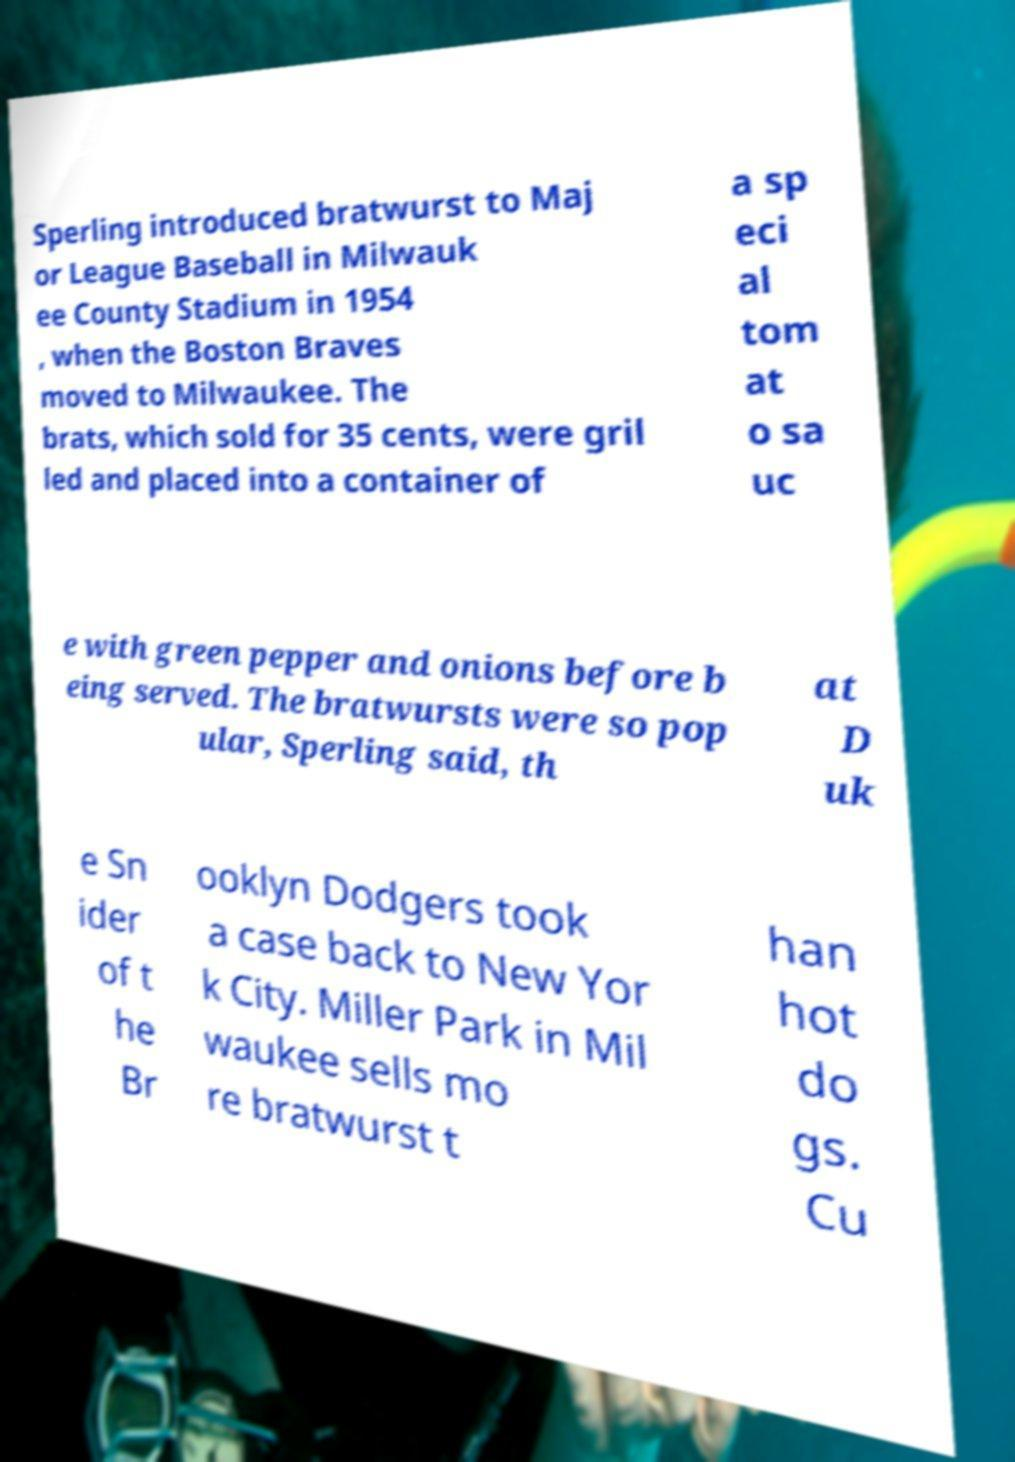For documentation purposes, I need the text within this image transcribed. Could you provide that? Sperling introduced bratwurst to Maj or League Baseball in Milwauk ee County Stadium in 1954 , when the Boston Braves moved to Milwaukee. The brats, which sold for 35 cents, were gril led and placed into a container of a sp eci al tom at o sa uc e with green pepper and onions before b eing served. The bratwursts were so pop ular, Sperling said, th at D uk e Sn ider of t he Br ooklyn Dodgers took a case back to New Yor k City. Miller Park in Mil waukee sells mo re bratwurst t han hot do gs. Cu 